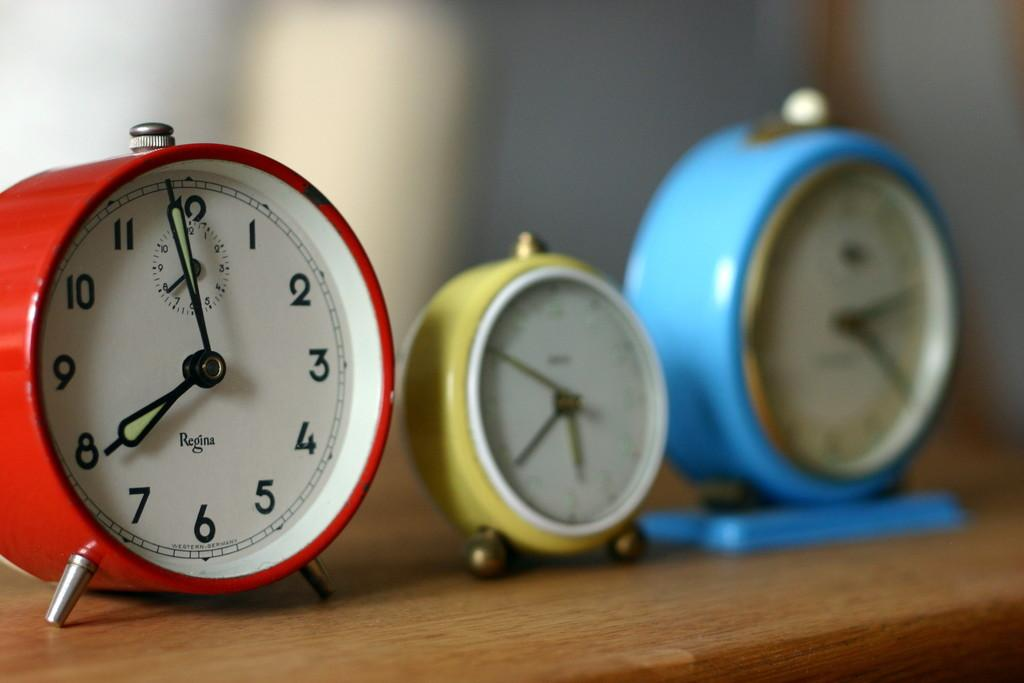How many table clocks are visible in the image? There are three table clocks in the image. What is the surface on which the table clocks are placed? The table clocks are on a wooden table. What type of prose can be heard being read from the books in the image? There are no books present in the image, so it is not possible to determine what type of prose might be read. 